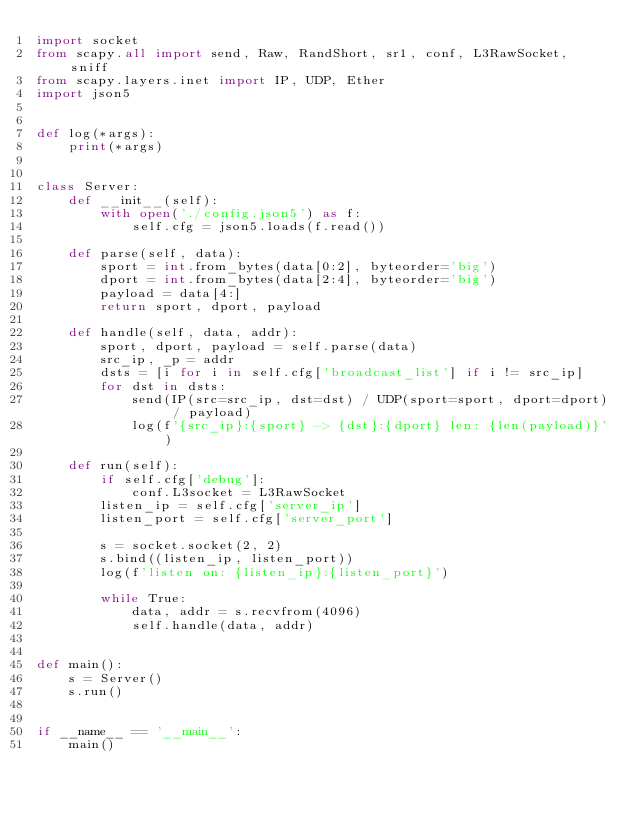<code> <loc_0><loc_0><loc_500><loc_500><_Python_>import socket
from scapy.all import send, Raw, RandShort, sr1, conf, L3RawSocket, sniff
from scapy.layers.inet import IP, UDP, Ether
import json5


def log(*args):
	print(*args)


class Server:
	def __init__(self):
		with open('./config.json5') as f:
			self.cfg = json5.loads(f.read())

	def parse(self, data):
		sport = int.from_bytes(data[0:2], byteorder='big')
		dport = int.from_bytes(data[2:4], byteorder='big')
		payload = data[4:]
		return sport, dport, payload

	def handle(self, data, addr):
		sport, dport, payload = self.parse(data)
		src_ip, _p = addr
		dsts = [i for i in self.cfg['broadcast_list'] if i != src_ip]
		for dst in dsts:
			send(IP(src=src_ip, dst=dst) / UDP(sport=sport, dport=dport) / payload)
			log(f'{src_ip}:{sport} -> {dst}:{dport} len: {len(payload)}')

	def run(self):
		if self.cfg['debug']:
			conf.L3socket = L3RawSocket
		listen_ip = self.cfg['server_ip']
		listen_port = self.cfg['server_port']

		s = socket.socket(2, 2)
		s.bind((listen_ip, listen_port))
		log(f'listen on: {listen_ip}:{listen_port}')

		while True:
			data, addr = s.recvfrom(4096)
			self.handle(data, addr)


def main():
	s = Server()
	s.run()


if __name__ == '__main__':
	main()
</code> 